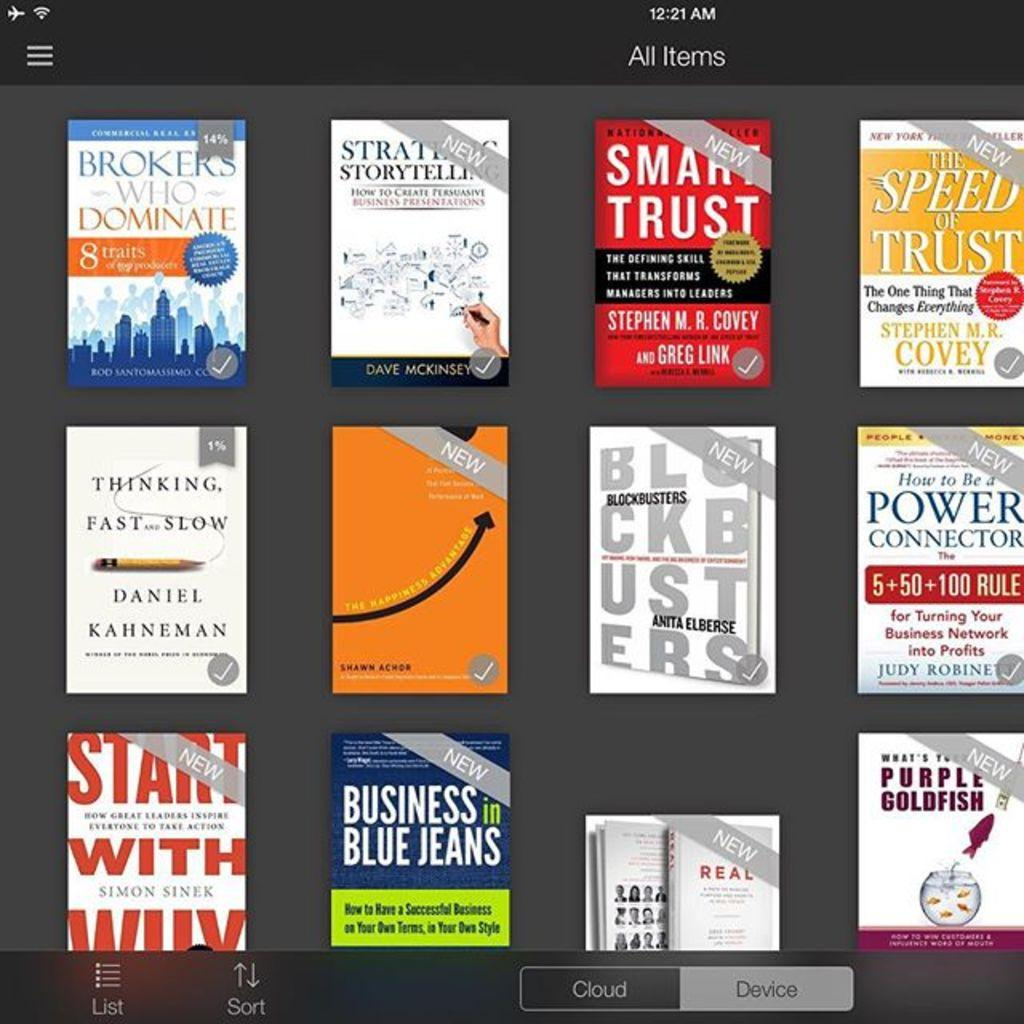Provide a one-sentence caption for the provided image. Several Ebooks like smart trust and business in blue jeans on a ebook app page. 